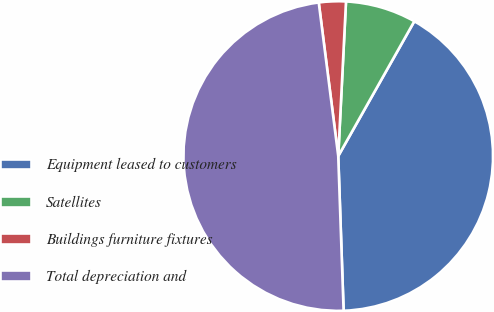Convert chart to OTSL. <chart><loc_0><loc_0><loc_500><loc_500><pie_chart><fcel>Equipment leased to customers<fcel>Satellites<fcel>Buildings furniture fixtures<fcel>Total depreciation and<nl><fcel>41.27%<fcel>7.38%<fcel>2.81%<fcel>48.54%<nl></chart> 